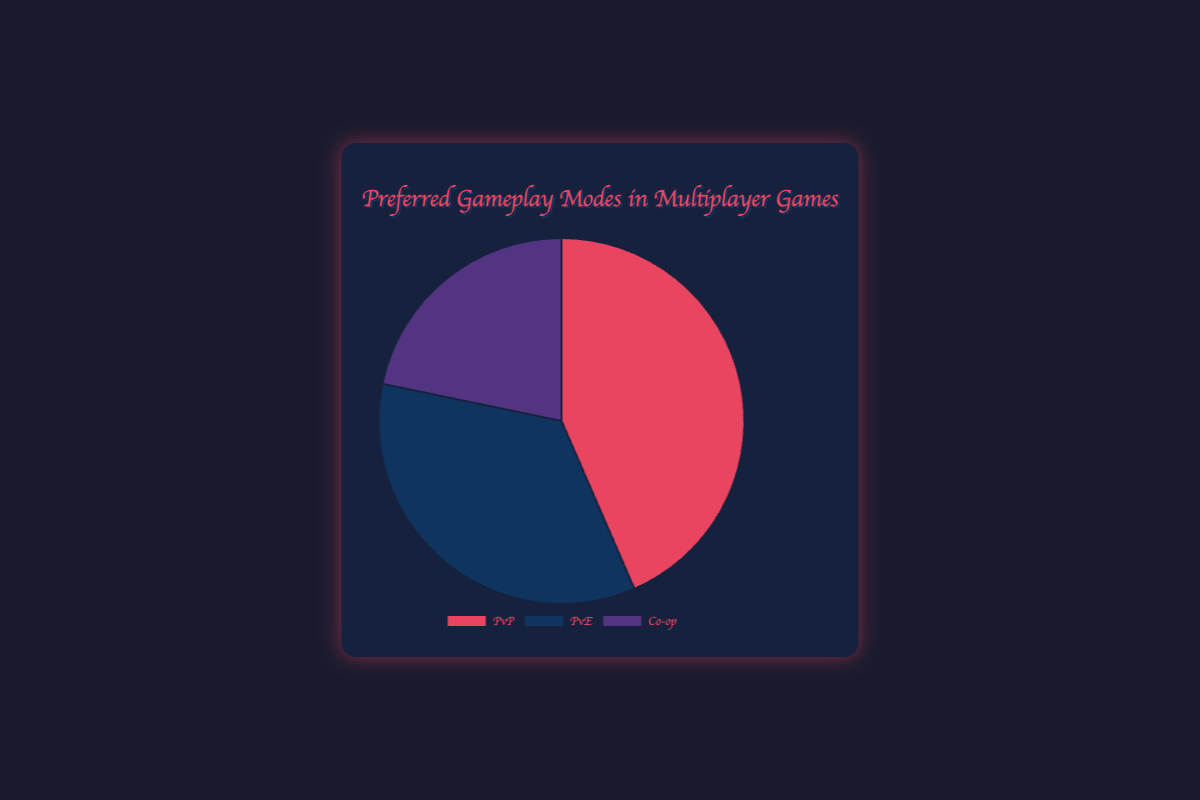What percentage of players prefer PvP modes? The figure shows the data points for three gameplay modes, including PvP, PvE, and Co-op. To find the percentage for PvP, simply refer to the corresponding slice of the pie chart labeled "PvP," which indicates 40%
Answer: 40% How much more popular is Co-op than PvE? To determine how much more popular Co-op is than PvE, look at the corresponding slices in the pie chart. Co-op is 20%, and PvE is 32%, so Co-op is 32% - 20% = 12% less popular than PvE
Answer: 12% less Which gameplay mode is the least preferred? To find the least preferred gameplay mode, look at the percentages for each mode in the pie chart: PvP (40%), PvE (32%), and Co-op (20%). The smallest percentage indicates the least preferred mode, which is Co-op at 20%
Answer: Co-op What is the total percentage of players who prefer either PvP or Co-op modes? Add the percentages of players who prefer PvP (40%) and Co-op (20%). The calculation is 40% + 20% = 60%
Answer: 60% Which mode has a larger slice in the pie chart, PvP or PvE, and by how much? Compare the slices representing PvP (40%) and PvE (32%) in the pie chart. PvP has a larger slice. The difference is 40% - 32% = 8%
Answer: PvP by 8% Is the percentage of players who prefer PvE greater than those who prefer Co-op? Compare the percentages for PvE (32%) and Co-op (20%) as shown in the pie chart. PvE's percentage is indeed greater
Answer: Yes By what percentage does the most preferred mode exceed the least preferred mode? Identify the highest and lowest percentages from the pie chart: PvP (40%) and Co-op (20%). The difference is 40% - 20% = 20%
Answer: 20% What is the combined percentage of players who do not prefer PvP modes? Add the percentages of players who prefer PvE (32%) and Co-op (20%). The sum is 32% + 20% = 52%
Answer: 52% Which mode has the closest percentage to 30%? Examine the percentages for each mode: PvP (40%), PvE (32%), and Co-op (20%). PvE with 32% is closest to 30%
Answer: PvE 